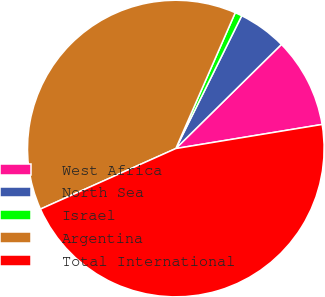<chart> <loc_0><loc_0><loc_500><loc_500><pie_chart><fcel>West Africa<fcel>North Sea<fcel>Israel<fcel>Argentina<fcel>Total International<nl><fcel>9.79%<fcel>5.28%<fcel>0.77%<fcel>38.26%<fcel>45.91%<nl></chart> 